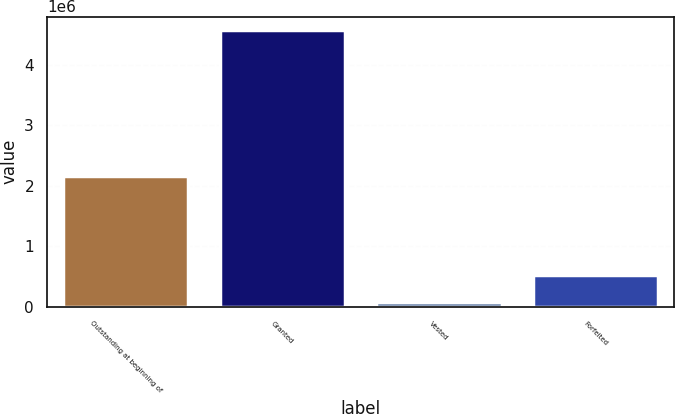<chart> <loc_0><loc_0><loc_500><loc_500><bar_chart><fcel>Outstanding at beginning of<fcel>Granted<fcel>Vested<fcel>Forfeited<nl><fcel>2.15402e+06<fcel>4.5635e+06<fcel>83444<fcel>531449<nl></chart> 